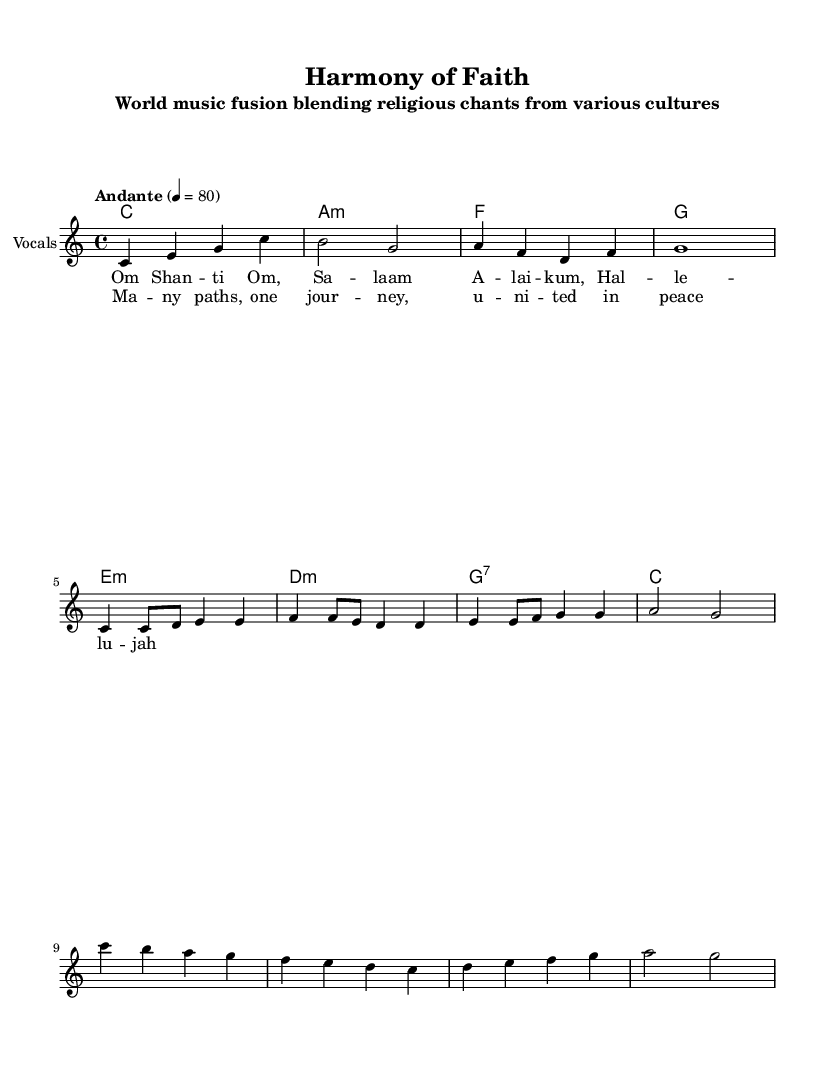What is the key signature of this music? The key signature is indicated as C major, which is shown by the absence of any sharps or flats in the beginning of the staff.
Answer: C major What is the time signature of this music? The time signature is noted as 4/4, which is visible at the start of the piece reflecting four beats in each measure.
Answer: 4/4 What is the tempo marking for this composition? The tempo marking is labeled as "Andante", indicating a moderate pace for the performance.
Answer: Andante How many measures are in the verse section? By counting the number of measures in the verse notation, there are a total of four measures in this section.
Answer: 4 What are the lyrics for the chorus? The chorus lyrics are provided in the lyric mode section and are "Many paths, one journey, united in peace."
Answer: Many paths, one journey, united in peace What is the first note of the melody? The first note of the melody is indicated as "C" in the notation, which appears at the beginning of the melody line.
Answer: C What type of harmony is primarily used in the choruses? The harmony type is demonstrated by the chord progression, which features open triads and seventh chords emphasizing the major and minor qualities.
Answer: Major and minor 